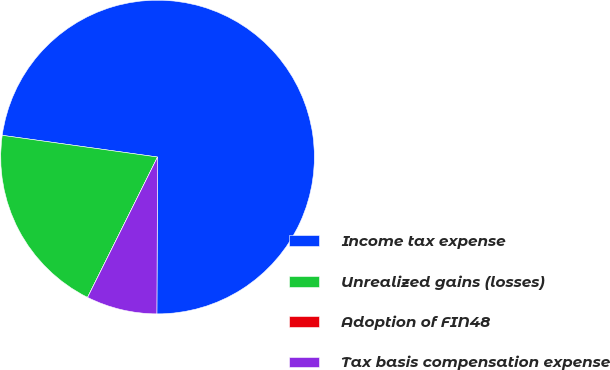<chart> <loc_0><loc_0><loc_500><loc_500><pie_chart><fcel>Income tax expense<fcel>Unrealized gains (losses)<fcel>Adoption of FIN48<fcel>Tax basis compensation expense<nl><fcel>72.86%<fcel>19.85%<fcel>0.0%<fcel>7.29%<nl></chart> 